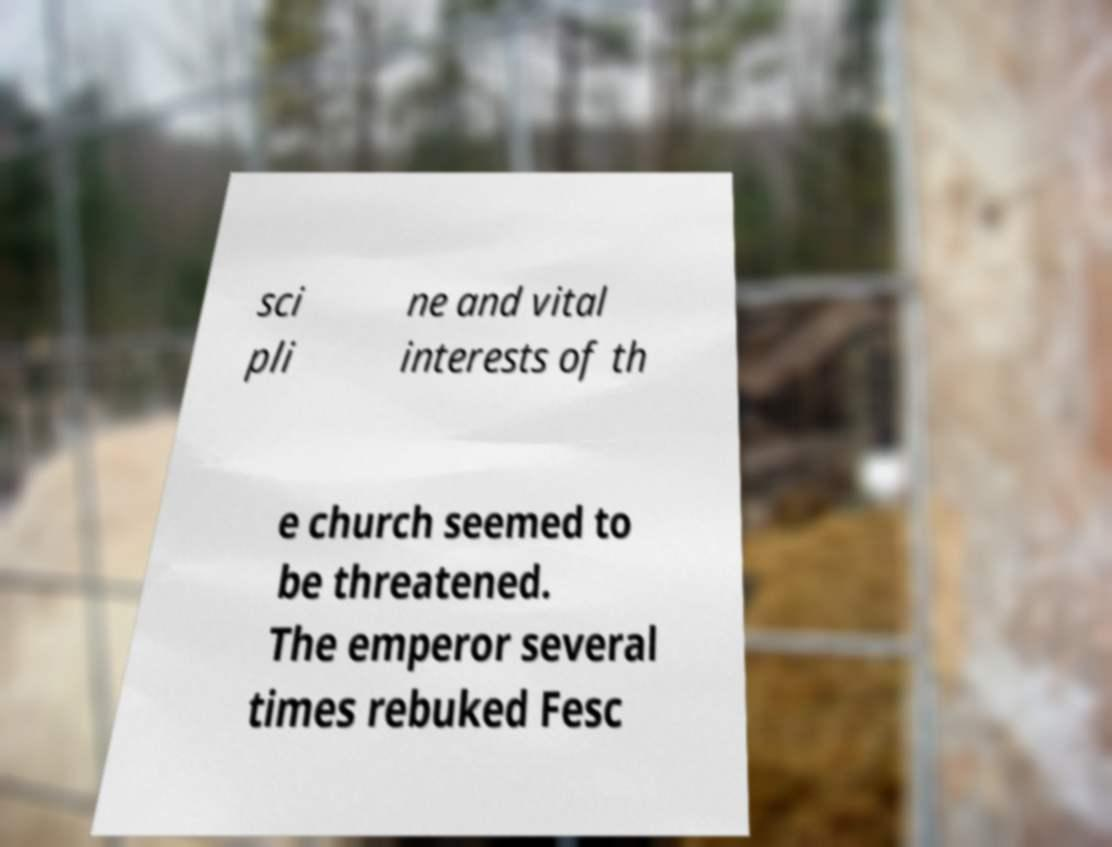Can you read and provide the text displayed in the image?This photo seems to have some interesting text. Can you extract and type it out for me? sci pli ne and vital interests of th e church seemed to be threatened. The emperor several times rebuked Fesc 